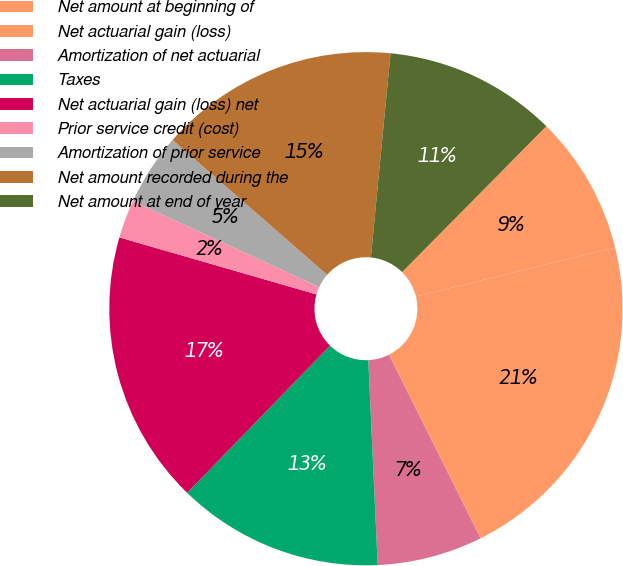<chart> <loc_0><loc_0><loc_500><loc_500><pie_chart><fcel>Net amount at beginning of<fcel>Net actuarial gain (loss)<fcel>Amortization of net actuarial<fcel>Taxes<fcel>Net actuarial gain (loss) net<fcel>Prior service credit (cost)<fcel>Amortization of prior service<fcel>Net amount recorded during the<fcel>Net amount at end of year<nl><fcel>8.76%<fcel>21.46%<fcel>6.64%<fcel>12.99%<fcel>17.22%<fcel>2.41%<fcel>4.53%<fcel>15.11%<fcel>10.88%<nl></chart> 